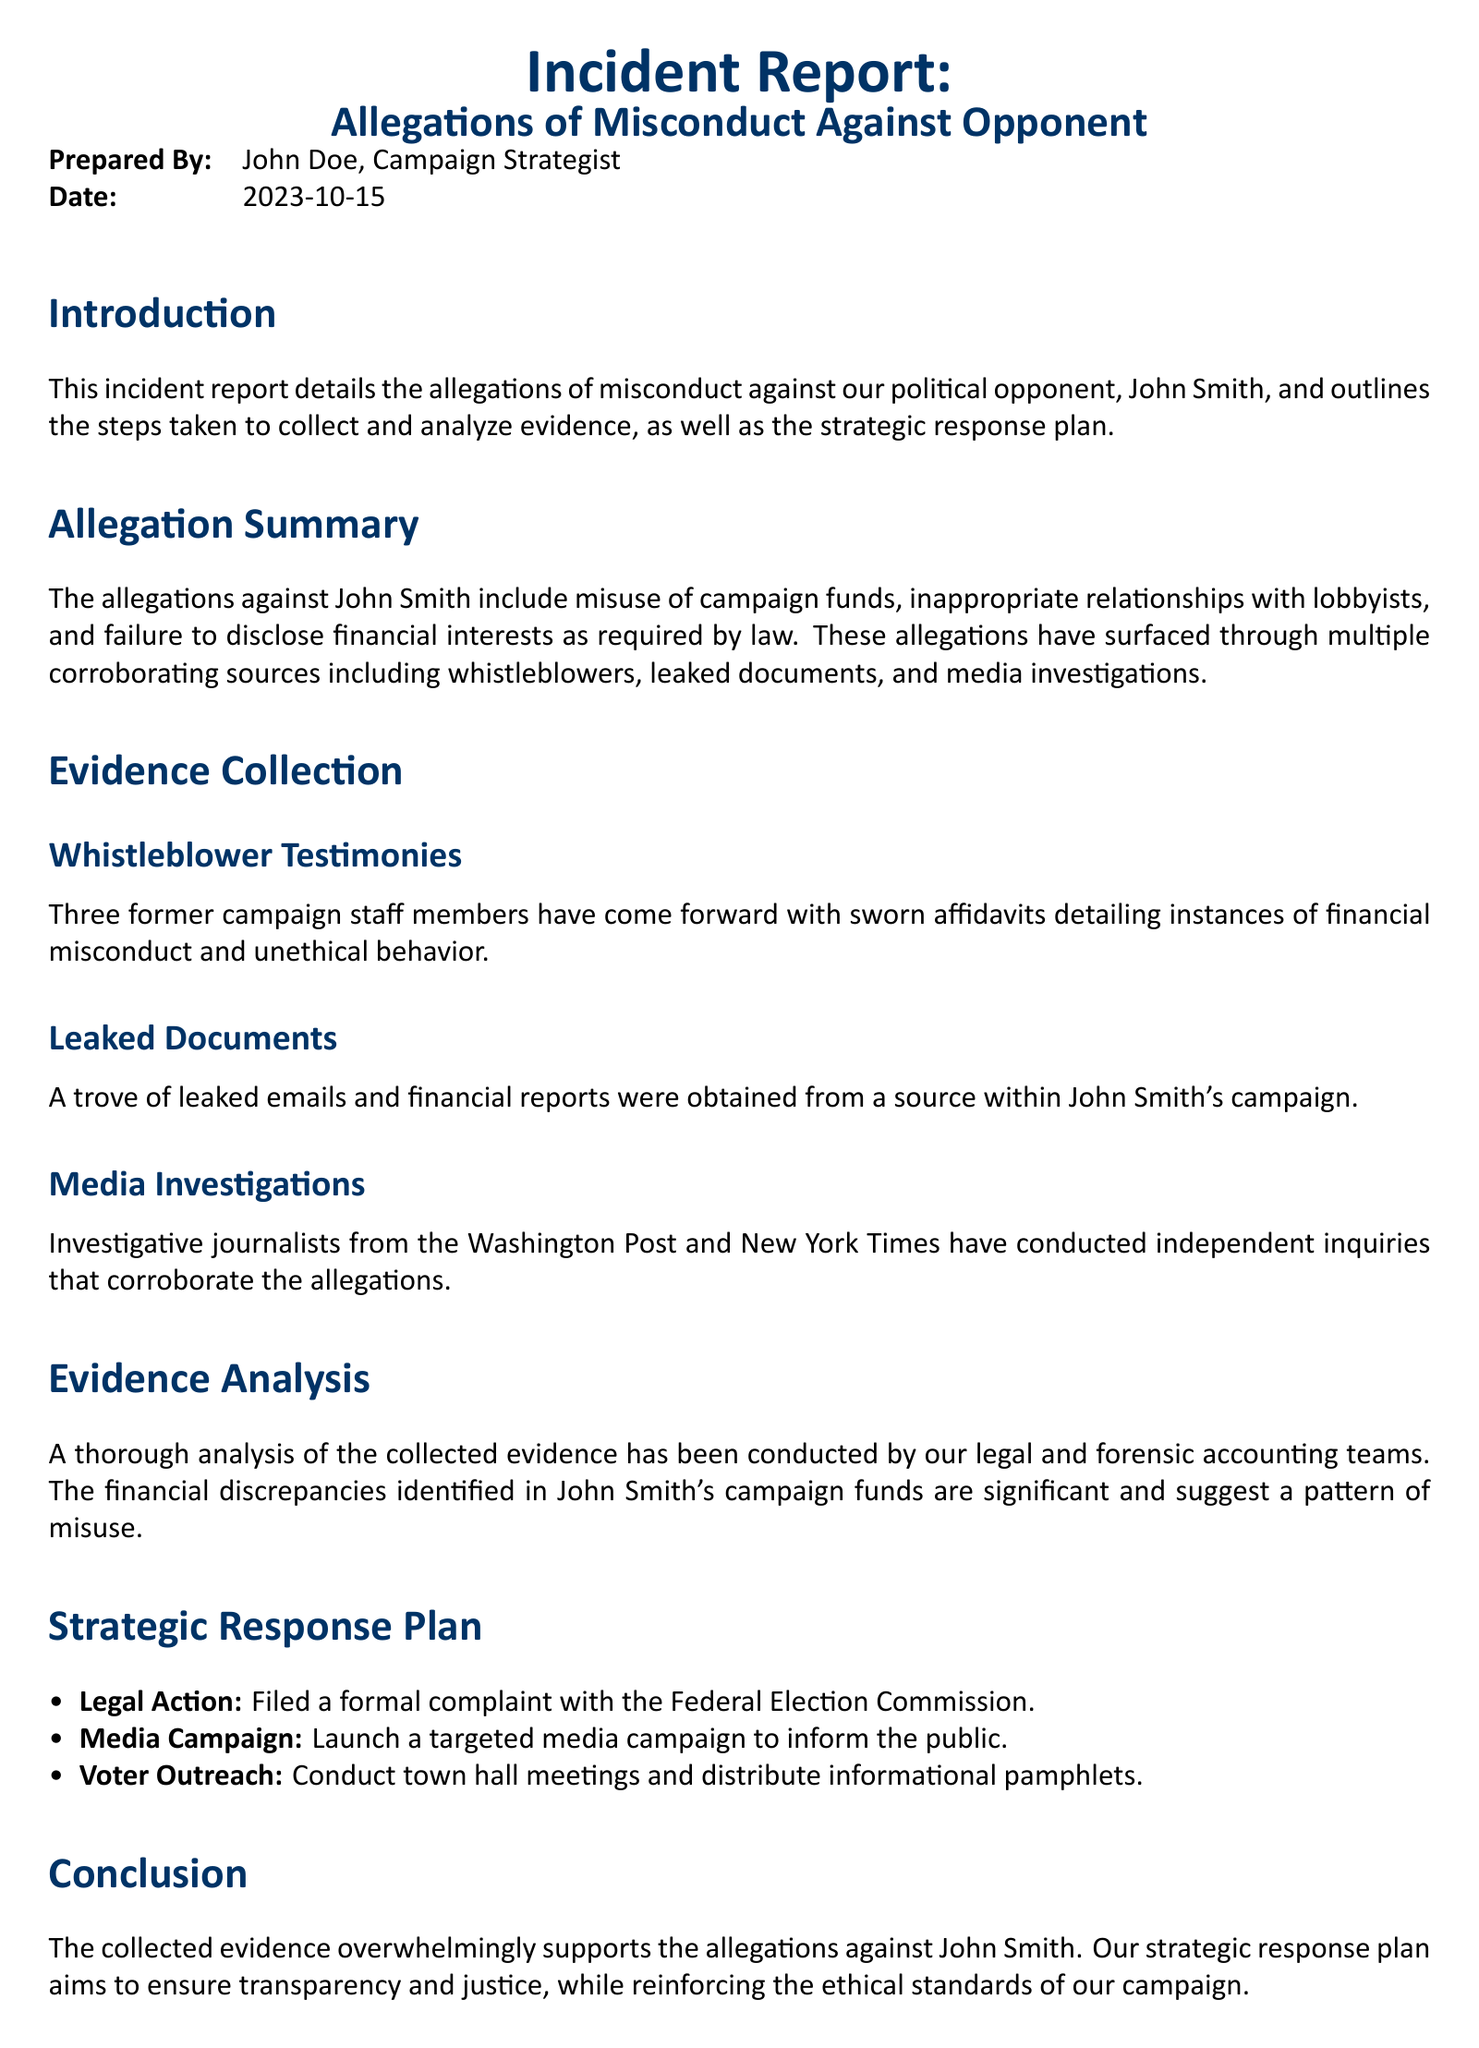What are the allegations against John Smith? The allegations include misuse of campaign funds, inappropriate relationships with lobbyists, and failure to disclose financial interests.
Answer: Misuse of campaign funds, inappropriate relationships with lobbyists, failure to disclose financial interests Who prepared the incident report? The report was prepared by John Doe, who is the campaign strategist.
Answer: John Doe What date was the incident report prepared? The date at the top of the document indicates when the report was prepared.
Answer: 2023-10-15 How many former campaign staff members provided testimonies? The report states that three former campaign staff members have come forward with sworn affidavits.
Answer: Three Which organizations conducted independent inquiries corroborating the allegations? The report mentions that investigative journalists from the Washington Post and New York Times conducted independent inquiries.
Answer: Washington Post and New York Times What is the first step in the strategic response plan? The first step listed under the strategic response plan is legal action by filing a formal complaint.
Answer: Legal Action What type of campaign will be launched to inform the public? The document specifies a targeted media campaign.
Answer: Targeted media campaign What is one of the methods suggested for voter outreach? The report suggests conducting town hall meetings as part of the voter outreach strategy.
Answer: Town hall meetings 